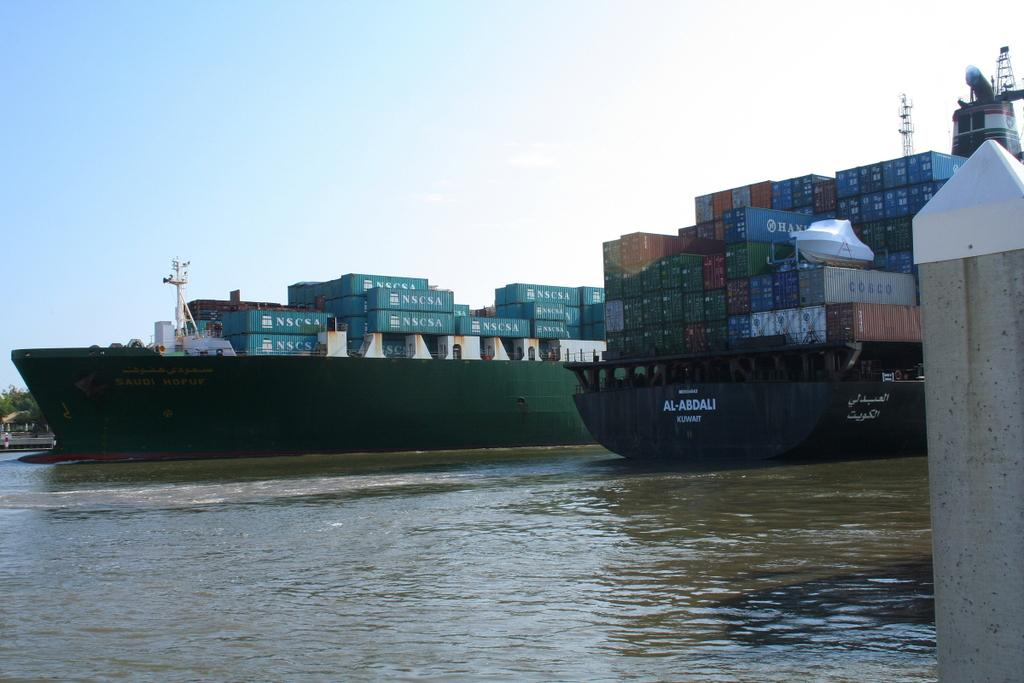Provide a one-sentence caption for the provided image. A ship that says Al-Abdali Kuwait is at dock along with another big ship. 